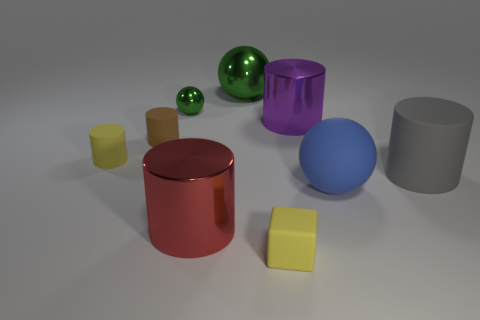The yellow cylinder that is made of the same material as the small block is what size?
Your response must be concise. Small. What color is the other small object that is made of the same material as the red thing?
Your answer should be compact. Green. Are there any purple shiny cylinders of the same size as the gray cylinder?
Give a very brief answer. Yes. There is another green thing that is the same shape as the tiny green object; what material is it?
Make the answer very short. Metal. The red metallic thing that is the same size as the purple metallic cylinder is what shape?
Provide a succinct answer. Cylinder. Are there any tiny green objects that have the same shape as the large red object?
Provide a succinct answer. No. The yellow matte object that is in front of the matte cylinder on the right side of the tiny matte cube is what shape?
Your answer should be compact. Cube. The blue thing is what shape?
Your response must be concise. Sphere. What is the material of the yellow object that is in front of the yellow thing that is on the left side of the small matte object that is in front of the large blue ball?
Provide a short and direct response. Rubber. How many other objects are the same material as the purple cylinder?
Make the answer very short. 3. 